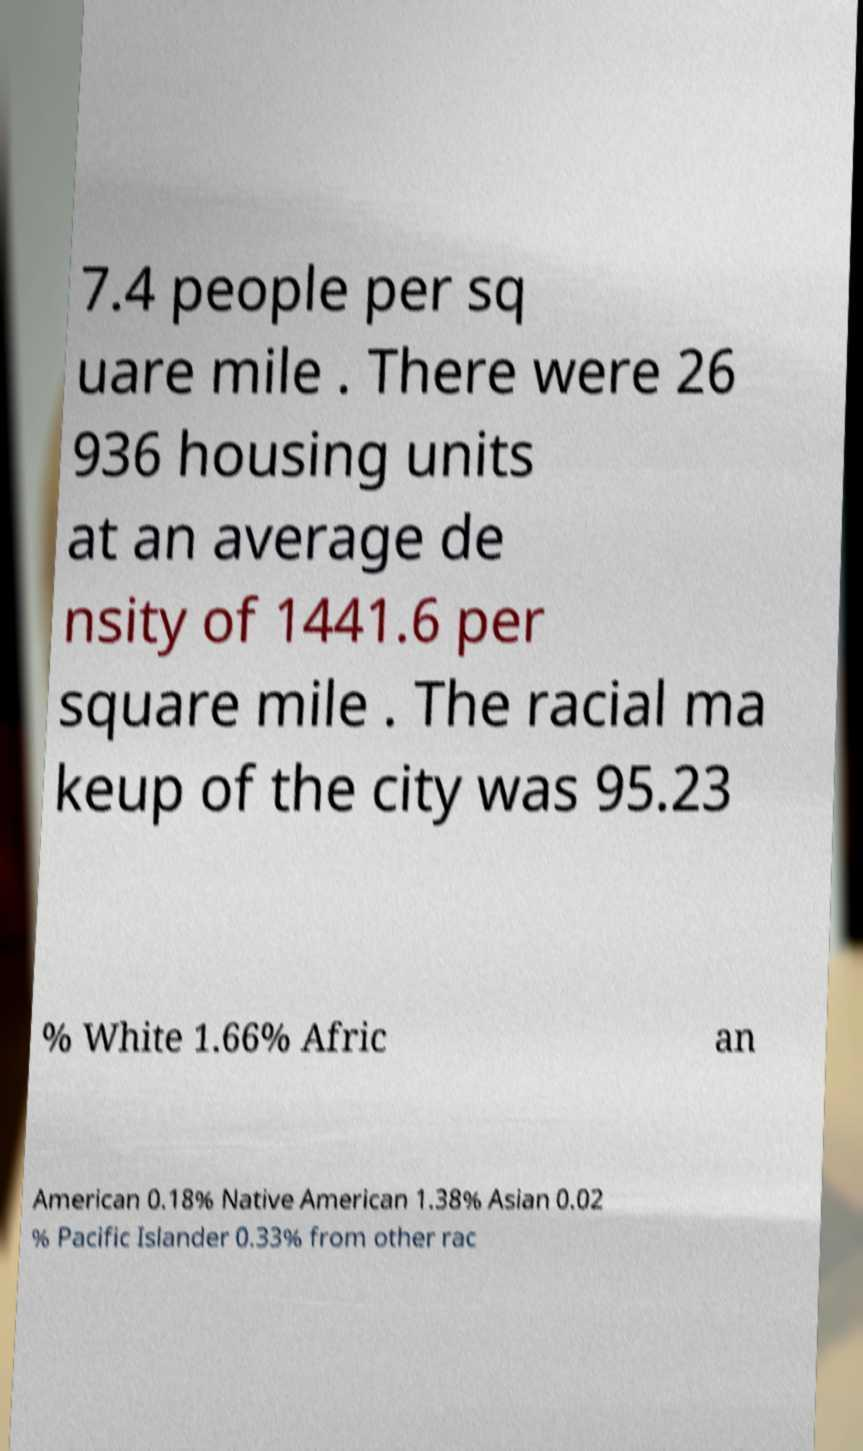Can you read and provide the text displayed in the image?This photo seems to have some interesting text. Can you extract and type it out for me? 7.4 people per sq uare mile . There were 26 936 housing units at an average de nsity of 1441.6 per square mile . The racial ma keup of the city was 95.23 % White 1.66% Afric an American 0.18% Native American 1.38% Asian 0.02 % Pacific Islander 0.33% from other rac 